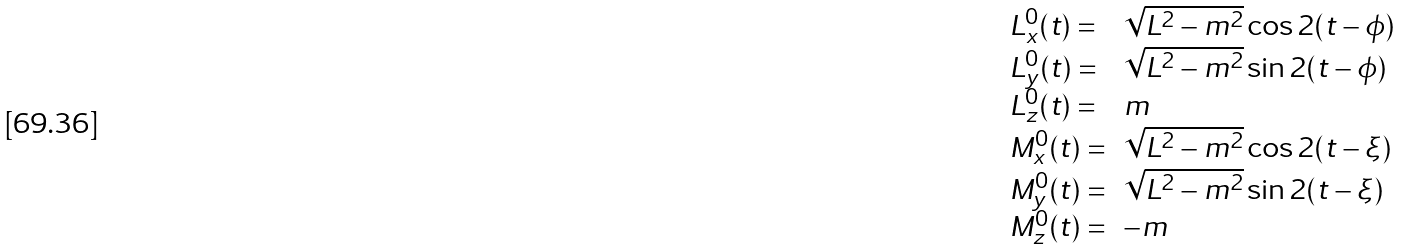<formula> <loc_0><loc_0><loc_500><loc_500>\begin{array} { l l } L _ { x } ^ { 0 } ( t ) = & \sqrt { L ^ { 2 } - m ^ { 2 } } \cos 2 ( t - \phi ) \\ L _ { y } ^ { 0 } ( t ) = & \sqrt { L ^ { 2 } - m ^ { 2 } } \sin 2 ( t - \phi ) \\ L _ { z } ^ { 0 } ( t ) = & m \\ M _ { x } ^ { 0 } ( t ) = & \sqrt { L ^ { 2 } - m ^ { 2 } } \cos 2 ( t - \xi ) \\ M _ { y } ^ { 0 } ( t ) = & \sqrt { L ^ { 2 } - m ^ { 2 } } \sin 2 ( t - \xi ) \\ M _ { z } ^ { 0 } ( t ) = & - m \end{array}</formula> 